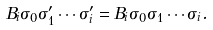<formula> <loc_0><loc_0><loc_500><loc_500>B _ { i } \sigma _ { 0 } \sigma ^ { \prime } _ { 1 } \cdots \sigma ^ { \prime } _ { i } = B _ { i } \sigma _ { 0 } \sigma _ { 1 } \cdots \sigma _ { i } .</formula> 